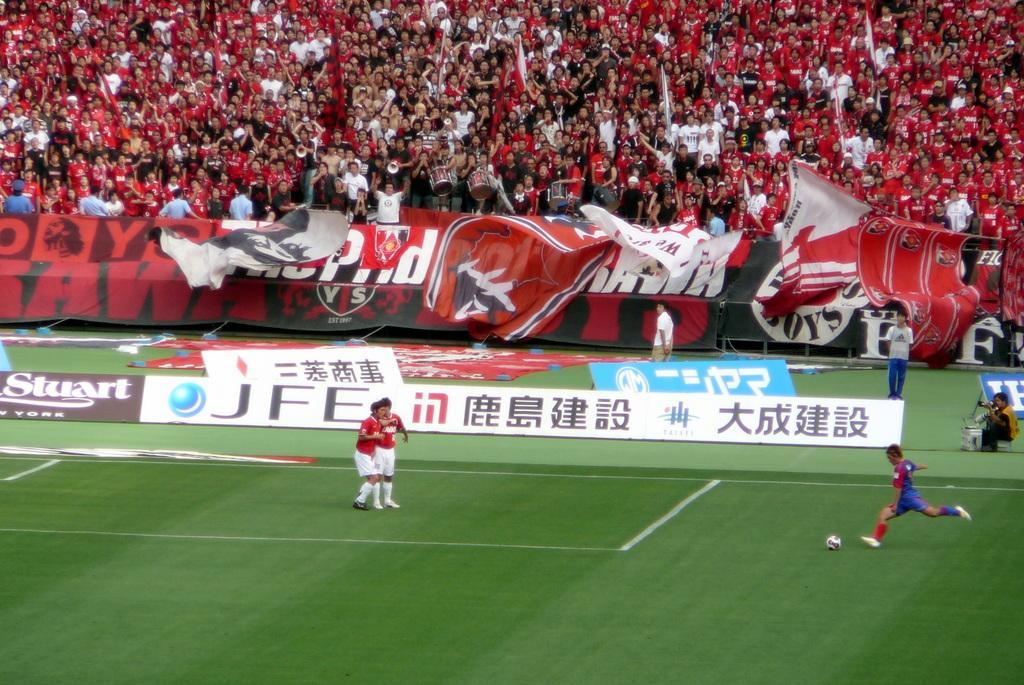Please provide a concise description of this image. In the image we can see there are people standing on the ground and there is a football on the ground. The ground is covered with grass and there are spectators watching them and holding flags in their hand. 